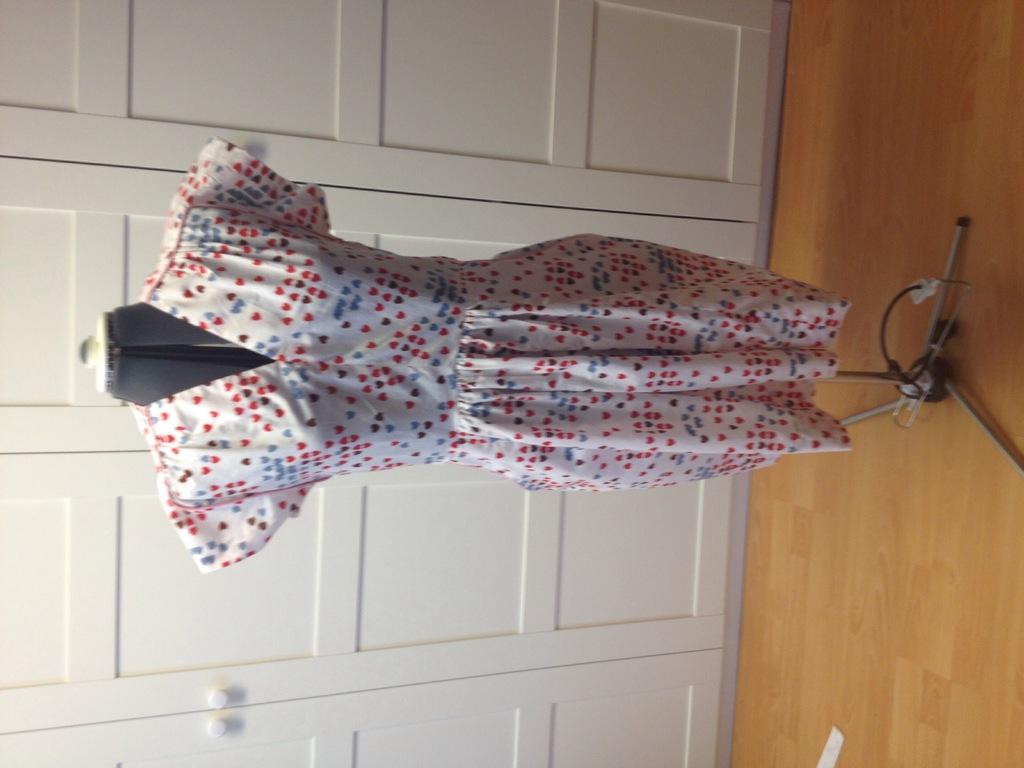What is the main subject in the center of the image? There is a dress on a stand in the center of the image. What can be seen in the background of the image? There are doors in the background of the image. What type of flooring is visible at the bottom of the image? There is wooden flooring at the bottom of the image. What type of coil is used to hold the dress on the stand? There is no coil present in the image; the dress is simply placed on the stand. 